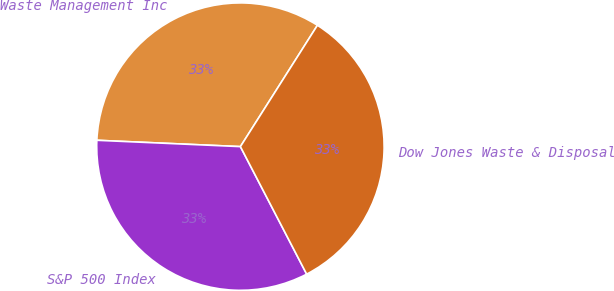Convert chart. <chart><loc_0><loc_0><loc_500><loc_500><pie_chart><fcel>Waste Management Inc<fcel>S&P 500 Index<fcel>Dow Jones Waste & Disposal<nl><fcel>33.3%<fcel>33.33%<fcel>33.37%<nl></chart> 